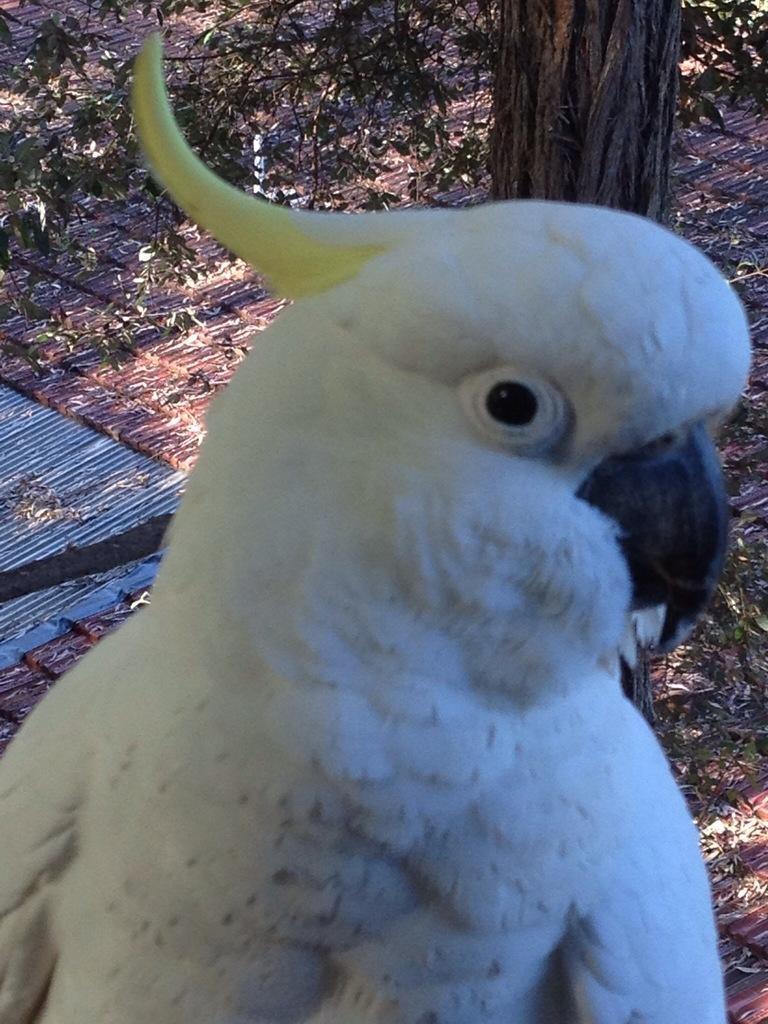In one or two sentences, can you explain what this image depicts? In this picture I can see a white color parrot in front. In the background I can see the leaves and the trunk of a tree. 